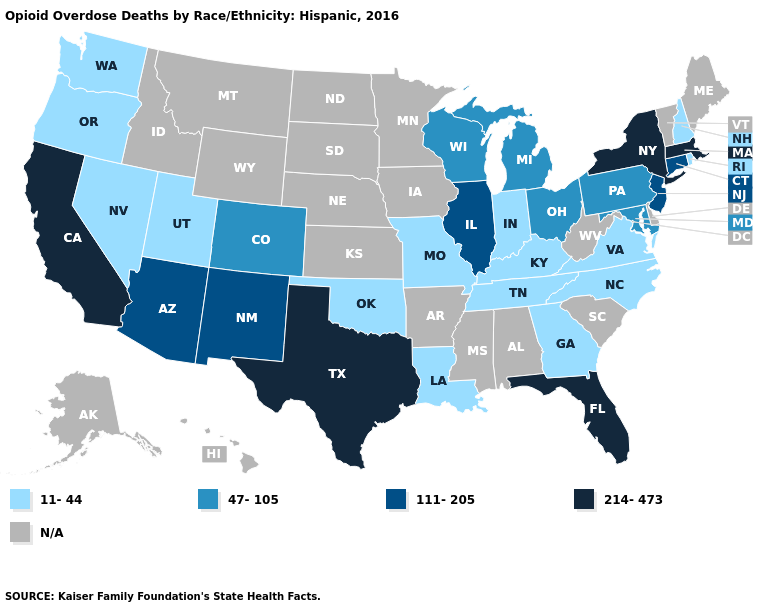What is the highest value in states that border Iowa?
Quick response, please. 111-205. Does the first symbol in the legend represent the smallest category?
Quick response, please. Yes. What is the value of Montana?
Write a very short answer. N/A. What is the value of Massachusetts?
Write a very short answer. 214-473. What is the value of Arizona?
Concise answer only. 111-205. Which states have the highest value in the USA?
Concise answer only. California, Florida, Massachusetts, New York, Texas. What is the value of Delaware?
Concise answer only. N/A. Name the states that have a value in the range 47-105?
Give a very brief answer. Colorado, Maryland, Michigan, Ohio, Pennsylvania, Wisconsin. What is the lowest value in states that border Tennessee?
Short answer required. 11-44. Among the states that border Missouri , does Illinois have the highest value?
Give a very brief answer. Yes. Does Georgia have the highest value in the USA?
Concise answer only. No. Does New York have the highest value in the USA?
Write a very short answer. Yes. Does Illinois have the highest value in the USA?
Quick response, please. No. What is the lowest value in states that border Pennsylvania?
Give a very brief answer. 47-105. Is the legend a continuous bar?
Concise answer only. No. 